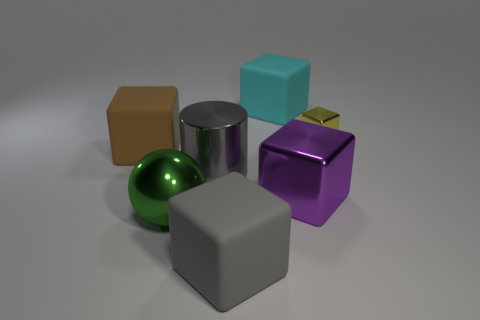There is a cube on the right side of the purple thing; how big is it?
Give a very brief answer. Small. How many yellow blocks are the same size as the yellow thing?
Your answer should be compact. 0. There is a thing that is both in front of the large brown cube and behind the big purple cube; what material is it made of?
Make the answer very short. Metal. There is a purple block that is the same size as the gray block; what material is it?
Offer a terse response. Metal. There is a shiny cube behind the large rubber block that is on the left side of the green object that is left of the big metal cylinder; what is its size?
Make the answer very short. Small. There is a yellow thing that is the same material as the ball; what is its size?
Provide a succinct answer. Small. There is a green ball; is it the same size as the gray object that is behind the big shiny cube?
Provide a short and direct response. Yes. What shape is the rubber thing that is behind the yellow shiny block?
Ensure brevity in your answer.  Cube. There is a shiny object behind the gray cylinder that is left of the large metallic block; are there any big rubber blocks that are in front of it?
Provide a succinct answer. Yes. What material is the big purple object that is the same shape as the cyan matte thing?
Give a very brief answer. Metal. 